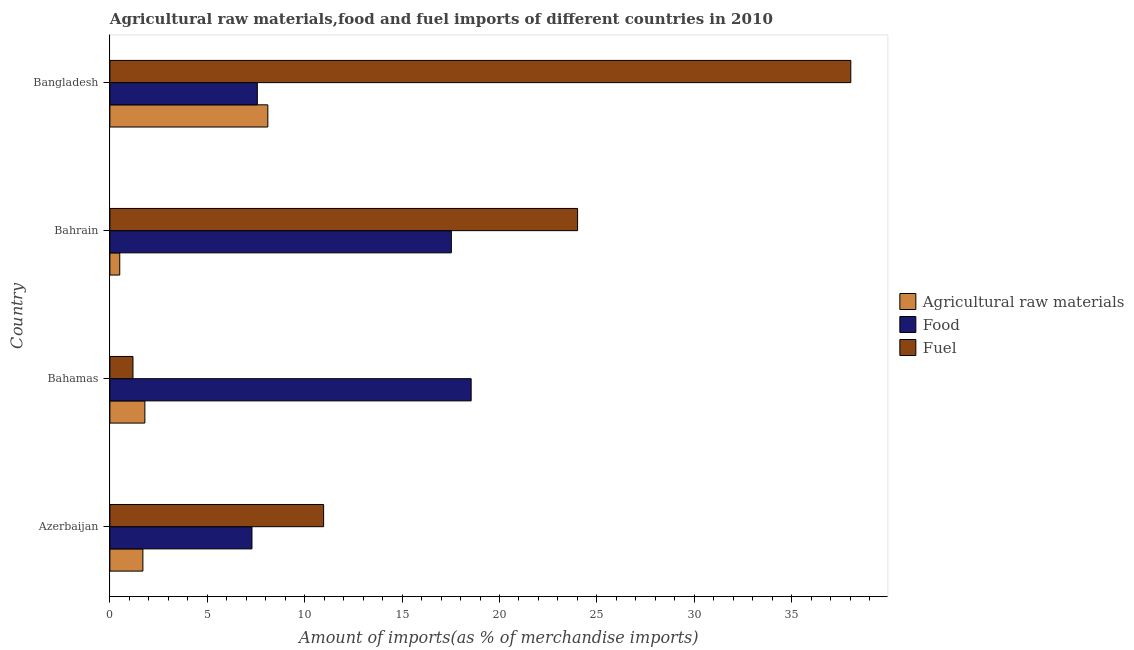How many different coloured bars are there?
Provide a succinct answer. 3. Are the number of bars per tick equal to the number of legend labels?
Your answer should be compact. Yes. What is the label of the 4th group of bars from the top?
Your answer should be very brief. Azerbaijan. In how many cases, is the number of bars for a given country not equal to the number of legend labels?
Ensure brevity in your answer.  0. What is the percentage of fuel imports in Azerbaijan?
Provide a short and direct response. 10.97. Across all countries, what is the maximum percentage of food imports?
Your answer should be very brief. 18.54. Across all countries, what is the minimum percentage of raw materials imports?
Provide a short and direct response. 0.51. In which country was the percentage of food imports maximum?
Provide a succinct answer. Bahamas. In which country was the percentage of food imports minimum?
Provide a short and direct response. Azerbaijan. What is the total percentage of fuel imports in the graph?
Ensure brevity in your answer.  74.2. What is the difference between the percentage of raw materials imports in Bahamas and that in Bahrain?
Your answer should be compact. 1.29. What is the difference between the percentage of fuel imports in Bangladesh and the percentage of raw materials imports in Bahamas?
Give a very brief answer. 36.24. What is the average percentage of food imports per country?
Your response must be concise. 12.73. What is the difference between the percentage of raw materials imports and percentage of fuel imports in Bahrain?
Your answer should be compact. -23.5. What is the ratio of the percentage of fuel imports in Bahrain to that in Bangladesh?
Ensure brevity in your answer.  0.63. What is the difference between the highest and the second highest percentage of fuel imports?
Provide a short and direct response. 14.02. What is the difference between the highest and the lowest percentage of food imports?
Provide a short and direct response. 11.25. In how many countries, is the percentage of raw materials imports greater than the average percentage of raw materials imports taken over all countries?
Provide a short and direct response. 1. Is the sum of the percentage of raw materials imports in Azerbaijan and Bahamas greater than the maximum percentage of fuel imports across all countries?
Provide a short and direct response. No. What does the 2nd bar from the top in Bahamas represents?
Your response must be concise. Food. What does the 2nd bar from the bottom in Bahrain represents?
Keep it short and to the point. Food. Are all the bars in the graph horizontal?
Offer a very short reply. Yes. How many countries are there in the graph?
Offer a terse response. 4. What is the difference between two consecutive major ticks on the X-axis?
Ensure brevity in your answer.  5. Does the graph contain any zero values?
Provide a short and direct response. No. Does the graph contain grids?
Your answer should be very brief. No. How many legend labels are there?
Offer a terse response. 3. How are the legend labels stacked?
Keep it short and to the point. Vertical. What is the title of the graph?
Your response must be concise. Agricultural raw materials,food and fuel imports of different countries in 2010. What is the label or title of the X-axis?
Give a very brief answer. Amount of imports(as % of merchandise imports). What is the Amount of imports(as % of merchandise imports) of Agricultural raw materials in Azerbaijan?
Offer a very short reply. 1.69. What is the Amount of imports(as % of merchandise imports) in Food in Azerbaijan?
Provide a short and direct response. 7.29. What is the Amount of imports(as % of merchandise imports) of Fuel in Azerbaijan?
Offer a terse response. 10.97. What is the Amount of imports(as % of merchandise imports) in Agricultural raw materials in Bahamas?
Provide a succinct answer. 1.8. What is the Amount of imports(as % of merchandise imports) in Food in Bahamas?
Your answer should be compact. 18.54. What is the Amount of imports(as % of merchandise imports) of Fuel in Bahamas?
Give a very brief answer. 1.18. What is the Amount of imports(as % of merchandise imports) in Agricultural raw materials in Bahrain?
Your answer should be compact. 0.51. What is the Amount of imports(as % of merchandise imports) of Food in Bahrain?
Offer a very short reply. 17.53. What is the Amount of imports(as % of merchandise imports) in Fuel in Bahrain?
Make the answer very short. 24.01. What is the Amount of imports(as % of merchandise imports) of Agricultural raw materials in Bangladesh?
Provide a short and direct response. 8.11. What is the Amount of imports(as % of merchandise imports) of Food in Bangladesh?
Give a very brief answer. 7.57. What is the Amount of imports(as % of merchandise imports) of Fuel in Bangladesh?
Make the answer very short. 38.03. Across all countries, what is the maximum Amount of imports(as % of merchandise imports) of Agricultural raw materials?
Keep it short and to the point. 8.11. Across all countries, what is the maximum Amount of imports(as % of merchandise imports) in Food?
Your response must be concise. 18.54. Across all countries, what is the maximum Amount of imports(as % of merchandise imports) of Fuel?
Offer a terse response. 38.03. Across all countries, what is the minimum Amount of imports(as % of merchandise imports) in Agricultural raw materials?
Make the answer very short. 0.51. Across all countries, what is the minimum Amount of imports(as % of merchandise imports) of Food?
Make the answer very short. 7.29. Across all countries, what is the minimum Amount of imports(as % of merchandise imports) in Fuel?
Offer a terse response. 1.18. What is the total Amount of imports(as % of merchandise imports) of Agricultural raw materials in the graph?
Your answer should be compact. 12.1. What is the total Amount of imports(as % of merchandise imports) in Food in the graph?
Offer a very short reply. 50.94. What is the total Amount of imports(as % of merchandise imports) of Fuel in the graph?
Give a very brief answer. 74.2. What is the difference between the Amount of imports(as % of merchandise imports) in Agricultural raw materials in Azerbaijan and that in Bahamas?
Offer a very short reply. -0.1. What is the difference between the Amount of imports(as % of merchandise imports) in Food in Azerbaijan and that in Bahamas?
Make the answer very short. -11.25. What is the difference between the Amount of imports(as % of merchandise imports) in Fuel in Azerbaijan and that in Bahamas?
Keep it short and to the point. 9.79. What is the difference between the Amount of imports(as % of merchandise imports) in Agricultural raw materials in Azerbaijan and that in Bahrain?
Provide a short and direct response. 1.19. What is the difference between the Amount of imports(as % of merchandise imports) in Food in Azerbaijan and that in Bahrain?
Provide a succinct answer. -10.24. What is the difference between the Amount of imports(as % of merchandise imports) of Fuel in Azerbaijan and that in Bahrain?
Provide a succinct answer. -13.04. What is the difference between the Amount of imports(as % of merchandise imports) in Agricultural raw materials in Azerbaijan and that in Bangladesh?
Keep it short and to the point. -6.41. What is the difference between the Amount of imports(as % of merchandise imports) of Food in Azerbaijan and that in Bangladesh?
Provide a succinct answer. -0.28. What is the difference between the Amount of imports(as % of merchandise imports) of Fuel in Azerbaijan and that in Bangladesh?
Your answer should be very brief. -27.06. What is the difference between the Amount of imports(as % of merchandise imports) in Agricultural raw materials in Bahamas and that in Bahrain?
Provide a succinct answer. 1.29. What is the difference between the Amount of imports(as % of merchandise imports) of Food in Bahamas and that in Bahrain?
Keep it short and to the point. 1.02. What is the difference between the Amount of imports(as % of merchandise imports) in Fuel in Bahamas and that in Bahrain?
Provide a short and direct response. -22.82. What is the difference between the Amount of imports(as % of merchandise imports) in Agricultural raw materials in Bahamas and that in Bangladesh?
Give a very brief answer. -6.31. What is the difference between the Amount of imports(as % of merchandise imports) of Food in Bahamas and that in Bangladesh?
Provide a short and direct response. 10.98. What is the difference between the Amount of imports(as % of merchandise imports) in Fuel in Bahamas and that in Bangladesh?
Make the answer very short. -36.85. What is the difference between the Amount of imports(as % of merchandise imports) in Agricultural raw materials in Bahrain and that in Bangladesh?
Provide a succinct answer. -7.6. What is the difference between the Amount of imports(as % of merchandise imports) of Food in Bahrain and that in Bangladesh?
Make the answer very short. 9.96. What is the difference between the Amount of imports(as % of merchandise imports) in Fuel in Bahrain and that in Bangladesh?
Keep it short and to the point. -14.02. What is the difference between the Amount of imports(as % of merchandise imports) in Agricultural raw materials in Azerbaijan and the Amount of imports(as % of merchandise imports) in Food in Bahamas?
Ensure brevity in your answer.  -16.85. What is the difference between the Amount of imports(as % of merchandise imports) of Agricultural raw materials in Azerbaijan and the Amount of imports(as % of merchandise imports) of Fuel in Bahamas?
Make the answer very short. 0.51. What is the difference between the Amount of imports(as % of merchandise imports) in Food in Azerbaijan and the Amount of imports(as % of merchandise imports) in Fuel in Bahamas?
Provide a short and direct response. 6.11. What is the difference between the Amount of imports(as % of merchandise imports) in Agricultural raw materials in Azerbaijan and the Amount of imports(as % of merchandise imports) in Food in Bahrain?
Give a very brief answer. -15.83. What is the difference between the Amount of imports(as % of merchandise imports) in Agricultural raw materials in Azerbaijan and the Amount of imports(as % of merchandise imports) in Fuel in Bahrain?
Ensure brevity in your answer.  -22.32. What is the difference between the Amount of imports(as % of merchandise imports) in Food in Azerbaijan and the Amount of imports(as % of merchandise imports) in Fuel in Bahrain?
Provide a short and direct response. -16.72. What is the difference between the Amount of imports(as % of merchandise imports) of Agricultural raw materials in Azerbaijan and the Amount of imports(as % of merchandise imports) of Food in Bangladesh?
Your response must be concise. -5.88. What is the difference between the Amount of imports(as % of merchandise imports) in Agricultural raw materials in Azerbaijan and the Amount of imports(as % of merchandise imports) in Fuel in Bangladesh?
Offer a terse response. -36.34. What is the difference between the Amount of imports(as % of merchandise imports) of Food in Azerbaijan and the Amount of imports(as % of merchandise imports) of Fuel in Bangladesh?
Keep it short and to the point. -30.74. What is the difference between the Amount of imports(as % of merchandise imports) of Agricultural raw materials in Bahamas and the Amount of imports(as % of merchandise imports) of Food in Bahrain?
Offer a terse response. -15.73. What is the difference between the Amount of imports(as % of merchandise imports) in Agricultural raw materials in Bahamas and the Amount of imports(as % of merchandise imports) in Fuel in Bahrain?
Your answer should be compact. -22.21. What is the difference between the Amount of imports(as % of merchandise imports) of Food in Bahamas and the Amount of imports(as % of merchandise imports) of Fuel in Bahrain?
Offer a terse response. -5.46. What is the difference between the Amount of imports(as % of merchandise imports) in Agricultural raw materials in Bahamas and the Amount of imports(as % of merchandise imports) in Food in Bangladesh?
Your answer should be compact. -5.77. What is the difference between the Amount of imports(as % of merchandise imports) in Agricultural raw materials in Bahamas and the Amount of imports(as % of merchandise imports) in Fuel in Bangladesh?
Your answer should be very brief. -36.24. What is the difference between the Amount of imports(as % of merchandise imports) of Food in Bahamas and the Amount of imports(as % of merchandise imports) of Fuel in Bangladesh?
Your response must be concise. -19.49. What is the difference between the Amount of imports(as % of merchandise imports) in Agricultural raw materials in Bahrain and the Amount of imports(as % of merchandise imports) in Food in Bangladesh?
Make the answer very short. -7.06. What is the difference between the Amount of imports(as % of merchandise imports) of Agricultural raw materials in Bahrain and the Amount of imports(as % of merchandise imports) of Fuel in Bangladesh?
Provide a short and direct response. -37.53. What is the difference between the Amount of imports(as % of merchandise imports) in Food in Bahrain and the Amount of imports(as % of merchandise imports) in Fuel in Bangladesh?
Your answer should be compact. -20.5. What is the average Amount of imports(as % of merchandise imports) of Agricultural raw materials per country?
Keep it short and to the point. 3.03. What is the average Amount of imports(as % of merchandise imports) of Food per country?
Make the answer very short. 12.73. What is the average Amount of imports(as % of merchandise imports) in Fuel per country?
Make the answer very short. 18.55. What is the difference between the Amount of imports(as % of merchandise imports) in Agricultural raw materials and Amount of imports(as % of merchandise imports) in Food in Azerbaijan?
Your response must be concise. -5.6. What is the difference between the Amount of imports(as % of merchandise imports) of Agricultural raw materials and Amount of imports(as % of merchandise imports) of Fuel in Azerbaijan?
Your answer should be very brief. -9.28. What is the difference between the Amount of imports(as % of merchandise imports) of Food and Amount of imports(as % of merchandise imports) of Fuel in Azerbaijan?
Ensure brevity in your answer.  -3.68. What is the difference between the Amount of imports(as % of merchandise imports) of Agricultural raw materials and Amount of imports(as % of merchandise imports) of Food in Bahamas?
Offer a very short reply. -16.75. What is the difference between the Amount of imports(as % of merchandise imports) of Agricultural raw materials and Amount of imports(as % of merchandise imports) of Fuel in Bahamas?
Your answer should be very brief. 0.61. What is the difference between the Amount of imports(as % of merchandise imports) of Food and Amount of imports(as % of merchandise imports) of Fuel in Bahamas?
Your answer should be compact. 17.36. What is the difference between the Amount of imports(as % of merchandise imports) of Agricultural raw materials and Amount of imports(as % of merchandise imports) of Food in Bahrain?
Give a very brief answer. -17.02. What is the difference between the Amount of imports(as % of merchandise imports) of Agricultural raw materials and Amount of imports(as % of merchandise imports) of Fuel in Bahrain?
Your response must be concise. -23.5. What is the difference between the Amount of imports(as % of merchandise imports) in Food and Amount of imports(as % of merchandise imports) in Fuel in Bahrain?
Provide a short and direct response. -6.48. What is the difference between the Amount of imports(as % of merchandise imports) in Agricultural raw materials and Amount of imports(as % of merchandise imports) in Food in Bangladesh?
Provide a short and direct response. 0.54. What is the difference between the Amount of imports(as % of merchandise imports) in Agricultural raw materials and Amount of imports(as % of merchandise imports) in Fuel in Bangladesh?
Your answer should be very brief. -29.93. What is the difference between the Amount of imports(as % of merchandise imports) of Food and Amount of imports(as % of merchandise imports) of Fuel in Bangladesh?
Provide a short and direct response. -30.46. What is the ratio of the Amount of imports(as % of merchandise imports) in Agricultural raw materials in Azerbaijan to that in Bahamas?
Your response must be concise. 0.94. What is the ratio of the Amount of imports(as % of merchandise imports) of Food in Azerbaijan to that in Bahamas?
Offer a terse response. 0.39. What is the ratio of the Amount of imports(as % of merchandise imports) of Fuel in Azerbaijan to that in Bahamas?
Provide a short and direct response. 9.26. What is the ratio of the Amount of imports(as % of merchandise imports) in Agricultural raw materials in Azerbaijan to that in Bahrain?
Make the answer very short. 3.35. What is the ratio of the Amount of imports(as % of merchandise imports) of Food in Azerbaijan to that in Bahrain?
Provide a succinct answer. 0.42. What is the ratio of the Amount of imports(as % of merchandise imports) of Fuel in Azerbaijan to that in Bahrain?
Offer a very short reply. 0.46. What is the ratio of the Amount of imports(as % of merchandise imports) in Agricultural raw materials in Azerbaijan to that in Bangladesh?
Keep it short and to the point. 0.21. What is the ratio of the Amount of imports(as % of merchandise imports) in Food in Azerbaijan to that in Bangladesh?
Give a very brief answer. 0.96. What is the ratio of the Amount of imports(as % of merchandise imports) in Fuel in Azerbaijan to that in Bangladesh?
Offer a very short reply. 0.29. What is the ratio of the Amount of imports(as % of merchandise imports) in Agricultural raw materials in Bahamas to that in Bahrain?
Offer a terse response. 3.55. What is the ratio of the Amount of imports(as % of merchandise imports) in Food in Bahamas to that in Bahrain?
Your answer should be very brief. 1.06. What is the ratio of the Amount of imports(as % of merchandise imports) of Fuel in Bahamas to that in Bahrain?
Your answer should be very brief. 0.05. What is the ratio of the Amount of imports(as % of merchandise imports) in Agricultural raw materials in Bahamas to that in Bangladesh?
Your answer should be very brief. 0.22. What is the ratio of the Amount of imports(as % of merchandise imports) of Food in Bahamas to that in Bangladesh?
Your answer should be very brief. 2.45. What is the ratio of the Amount of imports(as % of merchandise imports) in Fuel in Bahamas to that in Bangladesh?
Provide a succinct answer. 0.03. What is the ratio of the Amount of imports(as % of merchandise imports) of Agricultural raw materials in Bahrain to that in Bangladesh?
Provide a succinct answer. 0.06. What is the ratio of the Amount of imports(as % of merchandise imports) of Food in Bahrain to that in Bangladesh?
Make the answer very short. 2.32. What is the ratio of the Amount of imports(as % of merchandise imports) of Fuel in Bahrain to that in Bangladesh?
Provide a succinct answer. 0.63. What is the difference between the highest and the second highest Amount of imports(as % of merchandise imports) in Agricultural raw materials?
Ensure brevity in your answer.  6.31. What is the difference between the highest and the second highest Amount of imports(as % of merchandise imports) in Food?
Your response must be concise. 1.02. What is the difference between the highest and the second highest Amount of imports(as % of merchandise imports) of Fuel?
Provide a succinct answer. 14.02. What is the difference between the highest and the lowest Amount of imports(as % of merchandise imports) of Agricultural raw materials?
Your answer should be very brief. 7.6. What is the difference between the highest and the lowest Amount of imports(as % of merchandise imports) in Food?
Provide a succinct answer. 11.25. What is the difference between the highest and the lowest Amount of imports(as % of merchandise imports) of Fuel?
Make the answer very short. 36.85. 